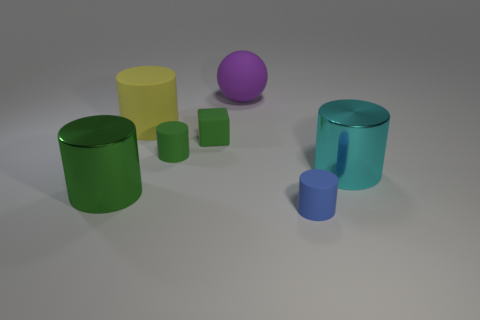Subtract all small green cylinders. How many cylinders are left? 4 Subtract all cyan cylinders. How many cylinders are left? 4 Add 1 shiny objects. How many objects exist? 8 Subtract 1 blocks. How many blocks are left? 0 Subtract all balls. How many objects are left? 6 Subtract all yellow spheres. How many green cylinders are left? 2 Subtract all brown cubes. Subtract all gray spheres. How many cubes are left? 1 Subtract all yellow things. Subtract all big objects. How many objects are left? 2 Add 1 metal objects. How many metal objects are left? 3 Add 6 tiny cyan shiny cubes. How many tiny cyan shiny cubes exist? 6 